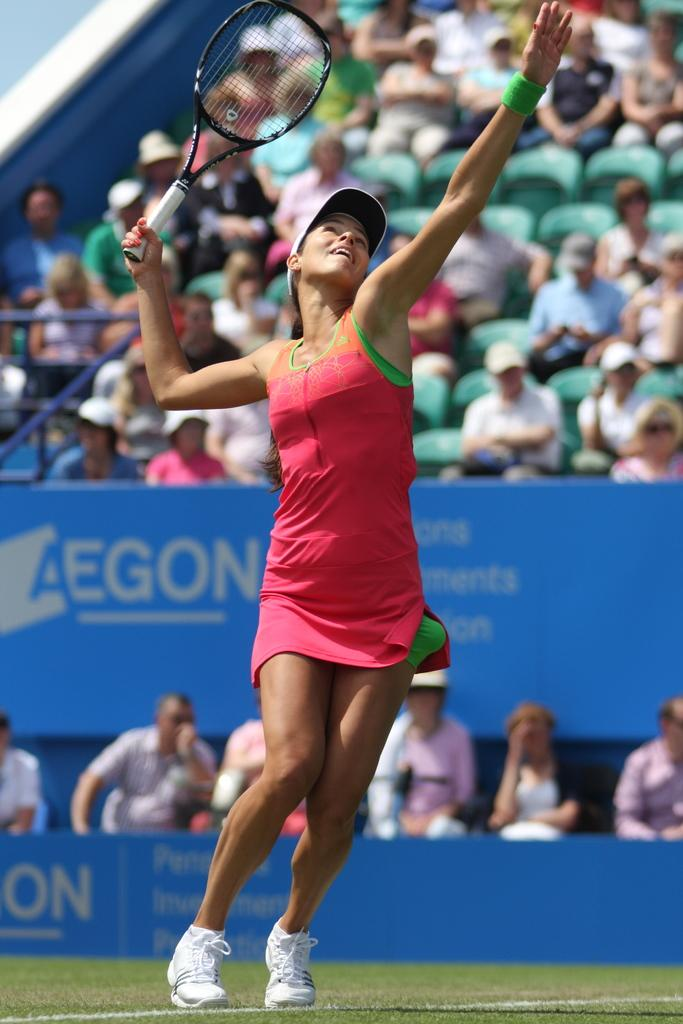Who is present in the image? There is a woman in the image. What is the woman doing in the image? The woman is standing and holding a racket. Can you describe the background of the image? There are people sitting on chairs in the background of the image. What type of fiction is the woman reading in the image? There is no book or any form of reading material present in the image, so it cannot be determined if the woman is reading fiction or any other type of content. 